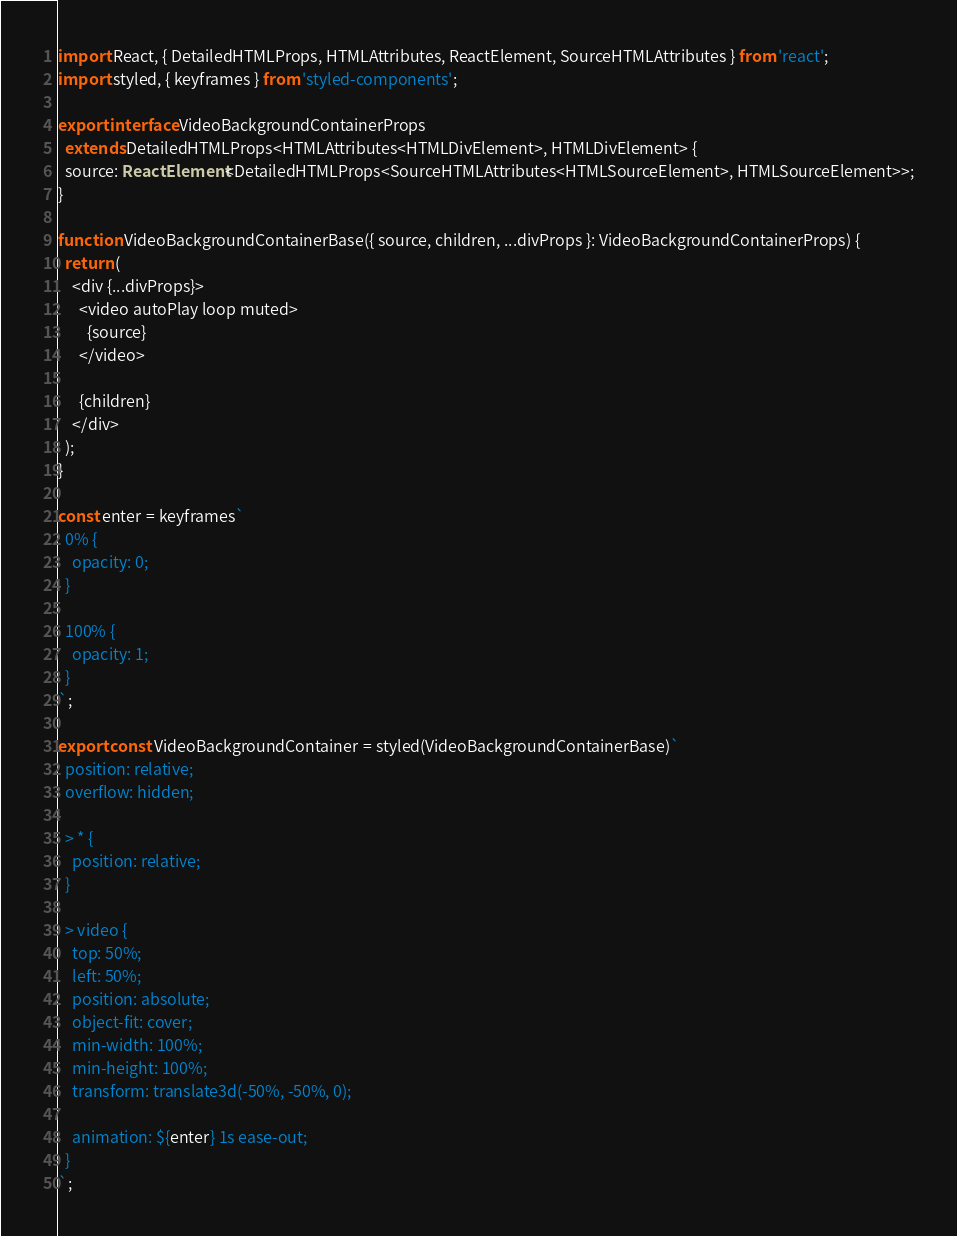Convert code to text. <code><loc_0><loc_0><loc_500><loc_500><_TypeScript_>import React, { DetailedHTMLProps, HTMLAttributes, ReactElement, SourceHTMLAttributes } from 'react';
import styled, { keyframes } from 'styled-components';

export interface VideoBackgroundContainerProps
  extends DetailedHTMLProps<HTMLAttributes<HTMLDivElement>, HTMLDivElement> {
  source: ReactElement<DetailedHTMLProps<SourceHTMLAttributes<HTMLSourceElement>, HTMLSourceElement>>;
}

function VideoBackgroundContainerBase({ source, children, ...divProps }: VideoBackgroundContainerProps) {
  return (
    <div {...divProps}>
      <video autoPlay loop muted>
        {source}
      </video>

      {children}
    </div>
  );
}

const enter = keyframes`
  0% {
    opacity: 0;
  }
  
  100% {
    opacity: 1;
  }
`;

export const VideoBackgroundContainer = styled(VideoBackgroundContainerBase)`
  position: relative;
  overflow: hidden;

  > * {
    position: relative;
  }

  > video {
    top: 50%;
    left: 50%;
    position: absolute;
    object-fit: cover;
    min-width: 100%;
    min-height: 100%;
    transform: translate3d(-50%, -50%, 0);

    animation: ${enter} 1s ease-out;
  }
`;
</code> 